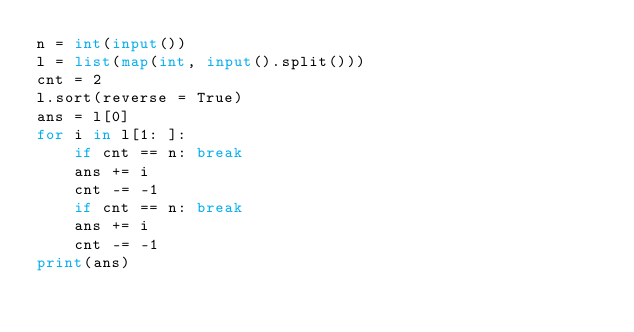Convert code to text. <code><loc_0><loc_0><loc_500><loc_500><_Python_>n = int(input())
l = list(map(int, input().split()))
cnt = 2
l.sort(reverse = True)
ans = l[0]
for i in l[1: ]:
    if cnt == n: break
    ans += i
    cnt -= -1
    if cnt == n: break
    ans += i
    cnt -= -1
print(ans)</code> 